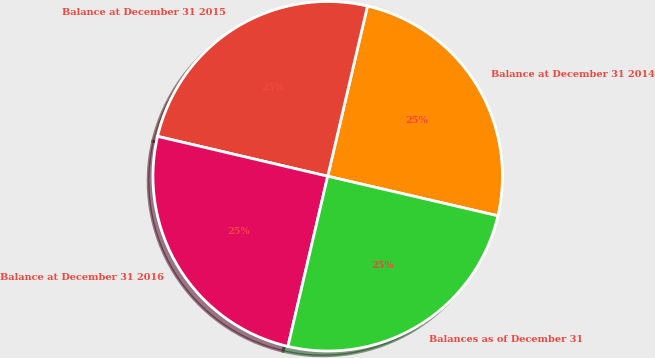<chart> <loc_0><loc_0><loc_500><loc_500><pie_chart><fcel>Balance at December 31 2014<fcel>Balance at December 31 2015<fcel>Balance at December 31 2016<fcel>Balances as of December 31<nl><fcel>24.98%<fcel>24.99%<fcel>25.01%<fcel>25.02%<nl></chart> 